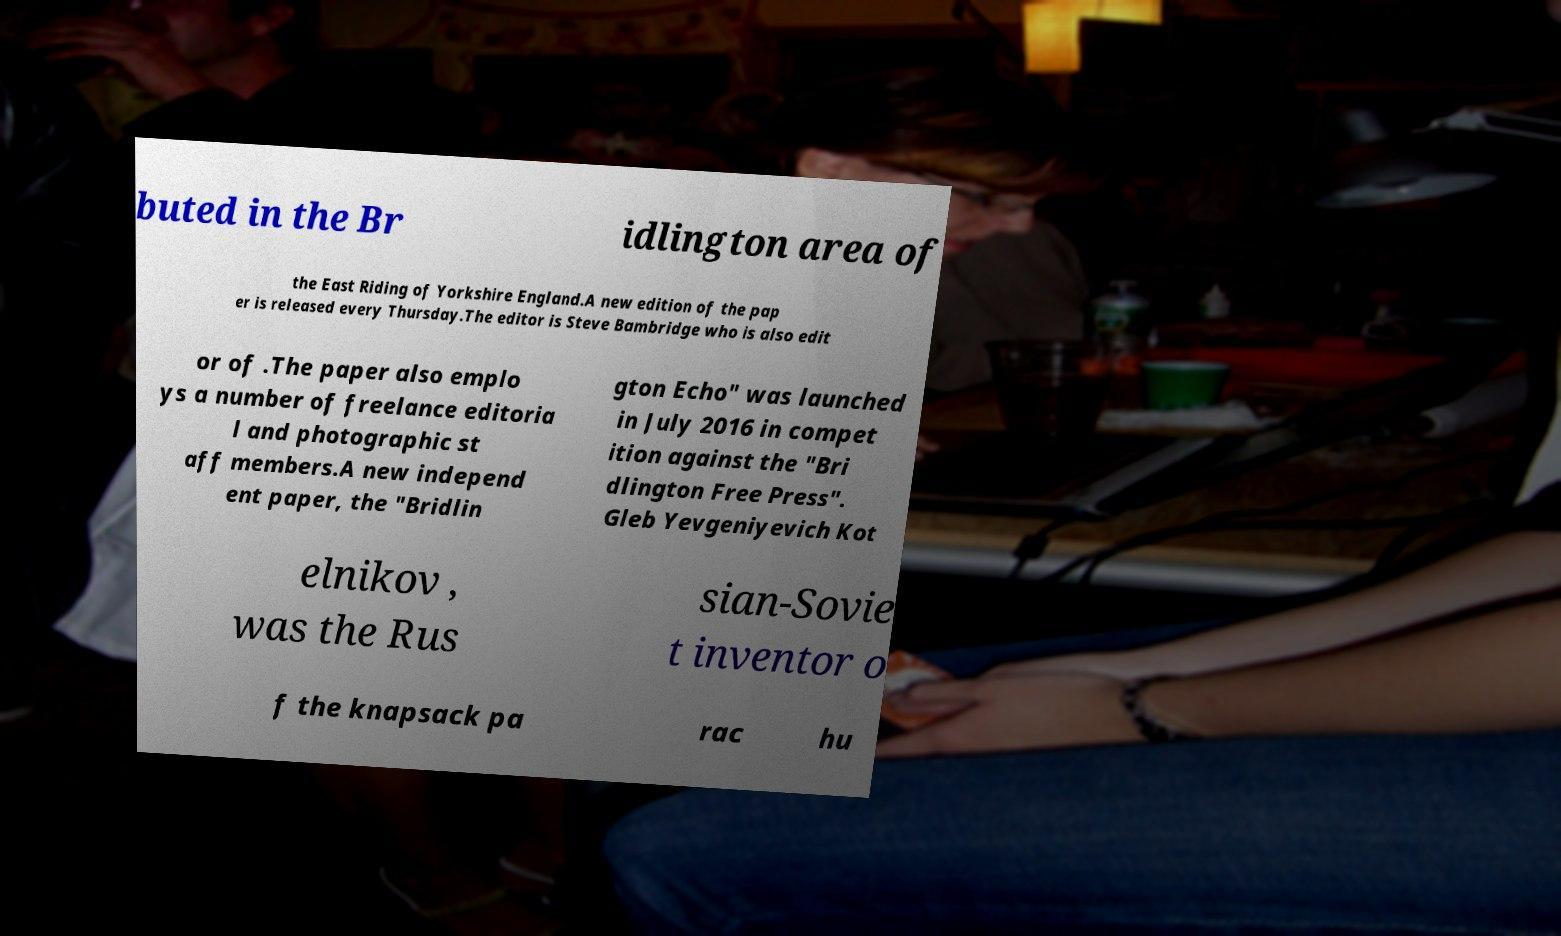There's text embedded in this image that I need extracted. Can you transcribe it verbatim? buted in the Br idlington area of the East Riding of Yorkshire England.A new edition of the pap er is released every Thursday.The editor is Steve Bambridge who is also edit or of .The paper also emplo ys a number of freelance editoria l and photographic st aff members.A new independ ent paper, the "Bridlin gton Echo" was launched in July 2016 in compet ition against the "Bri dlington Free Press". Gleb Yevgeniyevich Kot elnikov , was the Rus sian-Sovie t inventor o f the knapsack pa rac hu 